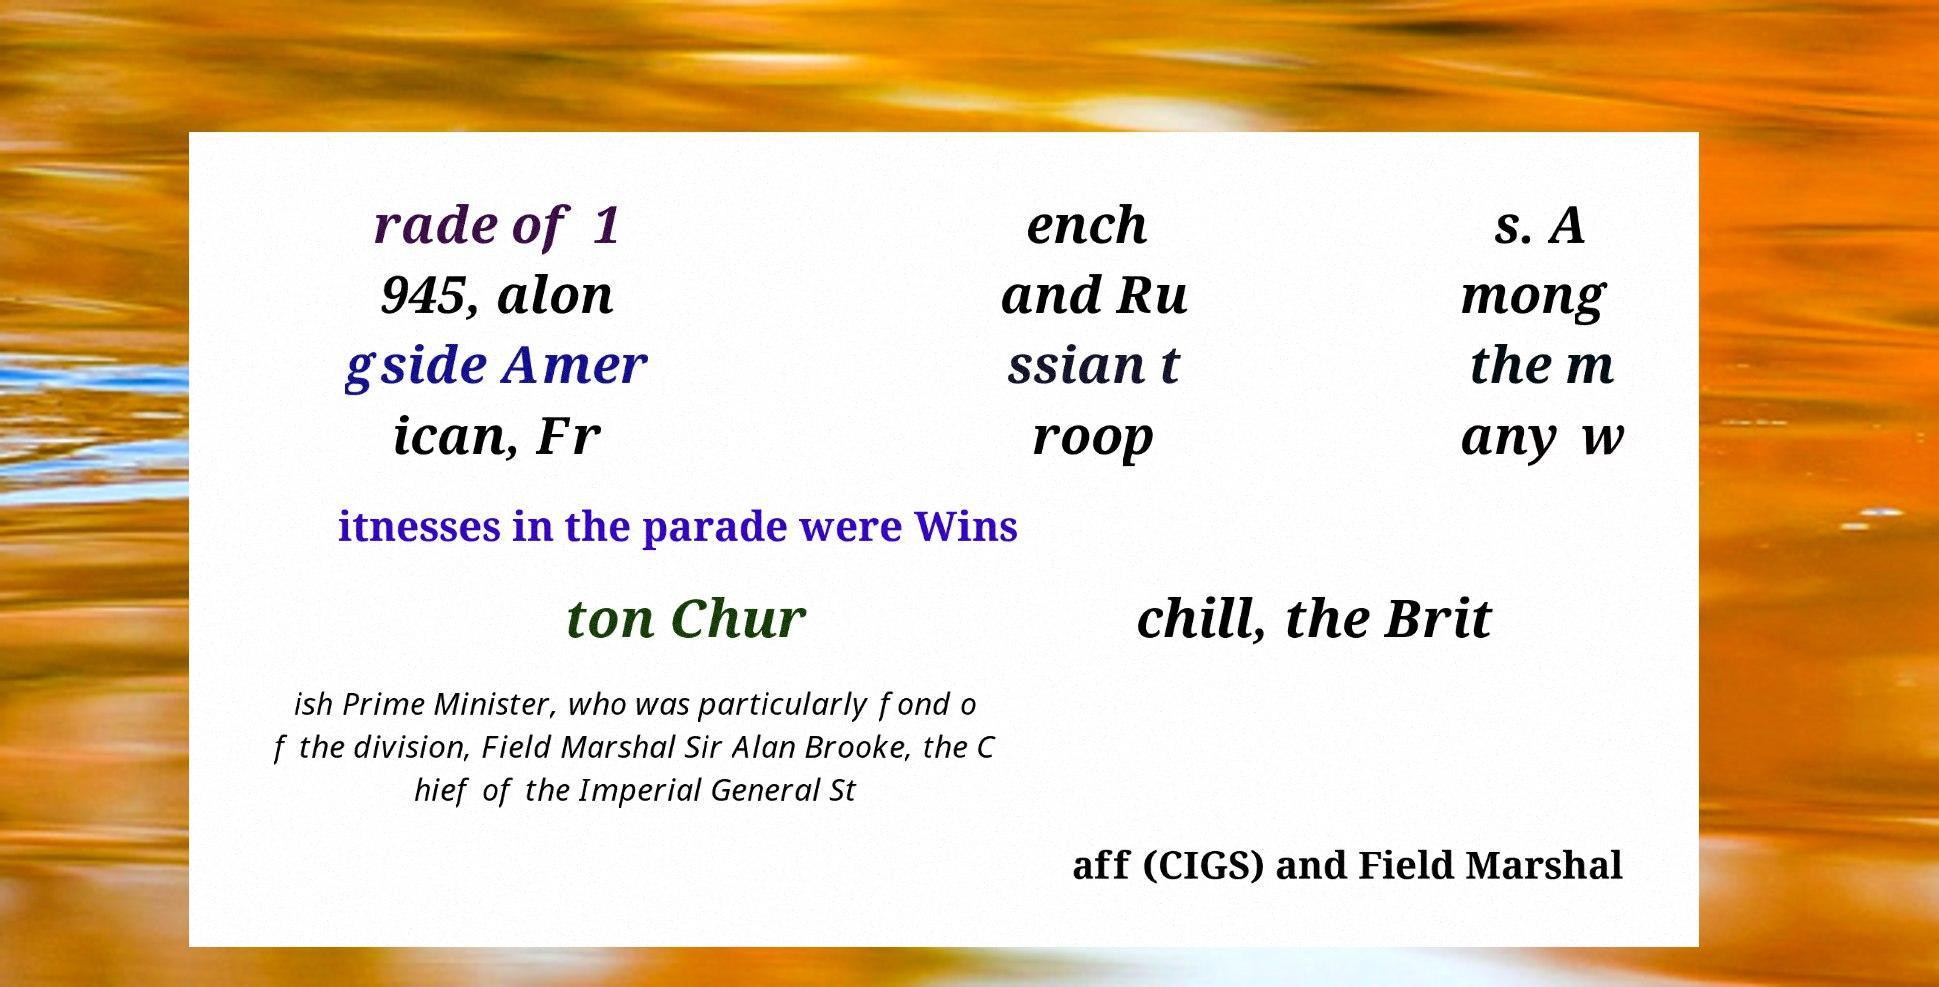Could you assist in decoding the text presented in this image and type it out clearly? rade of 1 945, alon gside Amer ican, Fr ench and Ru ssian t roop s. A mong the m any w itnesses in the parade were Wins ton Chur chill, the Brit ish Prime Minister, who was particularly fond o f the division, Field Marshal Sir Alan Brooke, the C hief of the Imperial General St aff (CIGS) and Field Marshal 